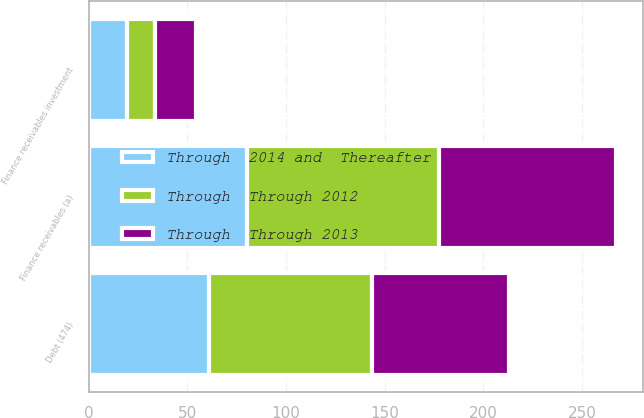Convert chart to OTSL. <chart><loc_0><loc_0><loc_500><loc_500><stacked_bar_chart><ecel><fcel>Finance receivables (a)<fcel>Debt (474)<fcel>Finance receivables investment<nl><fcel>Through  2014 and  Thereafter<fcel>80.5<fcel>60.8<fcel>19.7<nl><fcel>Through  Through 2013<fcel>89.8<fcel>69.1<fcel>20.7<nl><fcel>Through  Through 2012<fcel>97.1<fcel>83<fcel>14.1<nl></chart> 